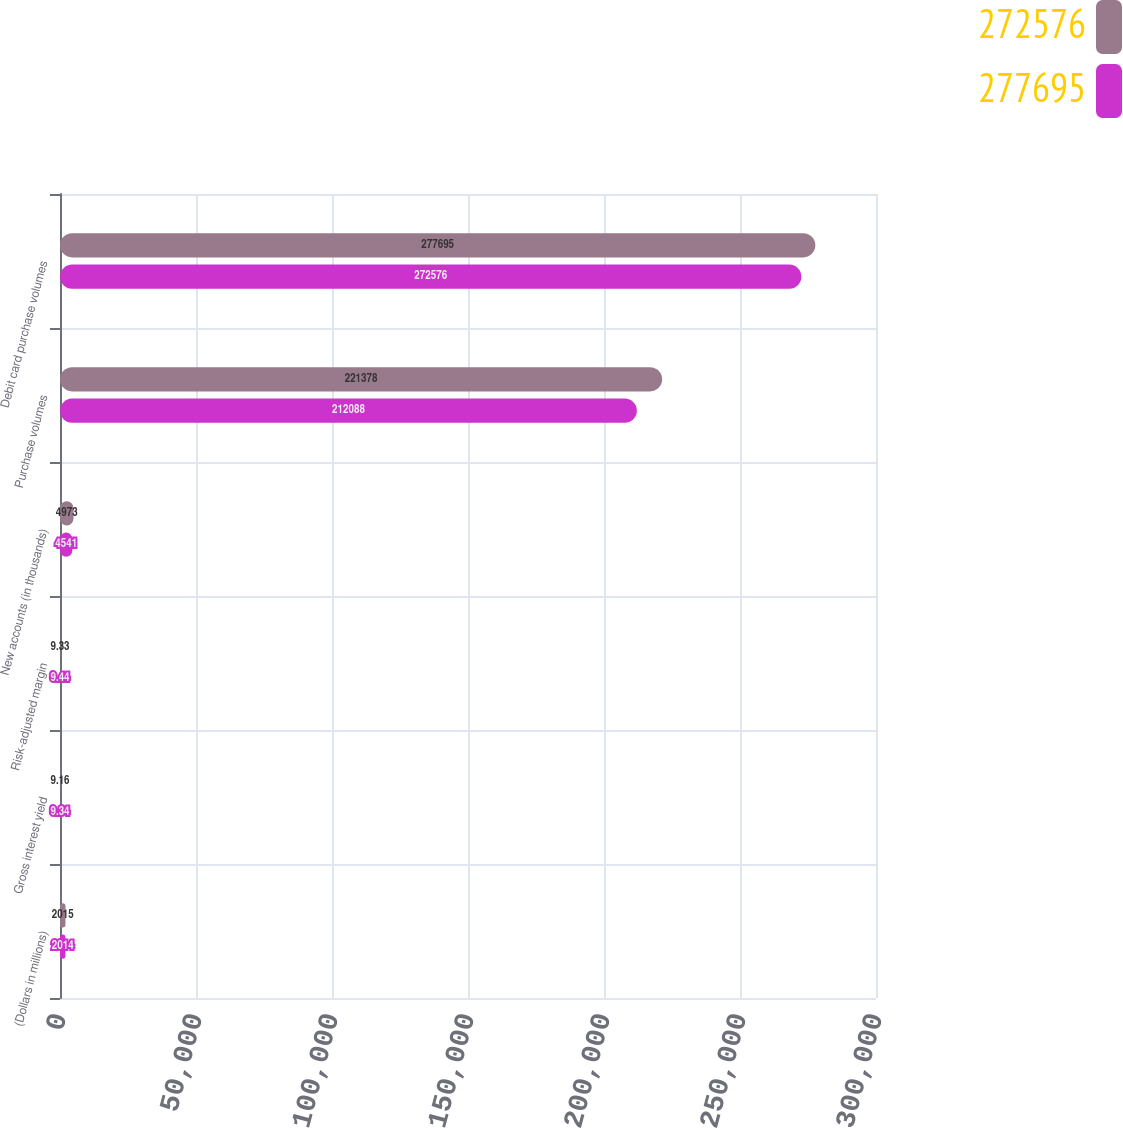Convert chart to OTSL. <chart><loc_0><loc_0><loc_500><loc_500><stacked_bar_chart><ecel><fcel>(Dollars in millions)<fcel>Gross interest yield<fcel>Risk-adjusted margin<fcel>New accounts (in thousands)<fcel>Purchase volumes<fcel>Debit card purchase volumes<nl><fcel>272576<fcel>2015<fcel>9.16<fcel>9.33<fcel>4973<fcel>221378<fcel>277695<nl><fcel>277695<fcel>2014<fcel>9.34<fcel>9.44<fcel>4541<fcel>212088<fcel>272576<nl></chart> 